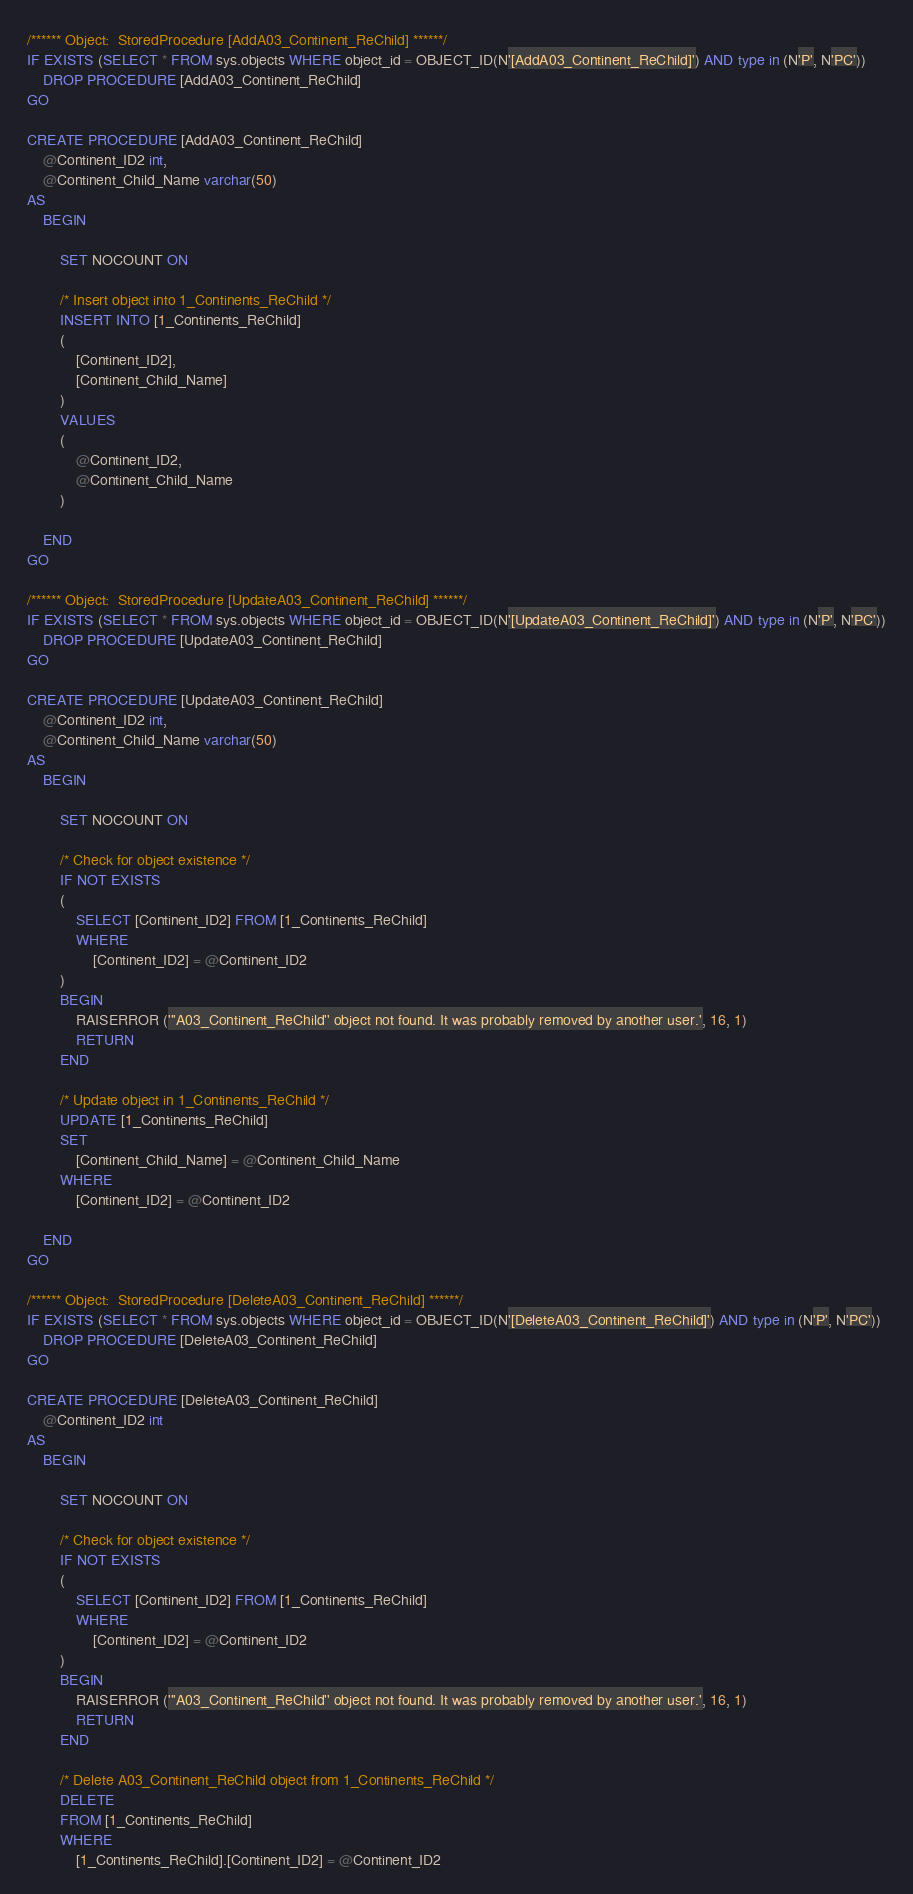<code> <loc_0><loc_0><loc_500><loc_500><_SQL_>/****** Object:  StoredProcedure [AddA03_Continent_ReChild] ******/
IF EXISTS (SELECT * FROM sys.objects WHERE object_id = OBJECT_ID(N'[AddA03_Continent_ReChild]') AND type in (N'P', N'PC'))
    DROP PROCEDURE [AddA03_Continent_ReChild]
GO

CREATE PROCEDURE [AddA03_Continent_ReChild]
    @Continent_ID2 int,
    @Continent_Child_Name varchar(50)
AS
    BEGIN

        SET NOCOUNT ON

        /* Insert object into 1_Continents_ReChild */
        INSERT INTO [1_Continents_ReChild]
        (
            [Continent_ID2],
            [Continent_Child_Name]
        )
        VALUES
        (
            @Continent_ID2,
            @Continent_Child_Name
        )

    END
GO

/****** Object:  StoredProcedure [UpdateA03_Continent_ReChild] ******/
IF EXISTS (SELECT * FROM sys.objects WHERE object_id = OBJECT_ID(N'[UpdateA03_Continent_ReChild]') AND type in (N'P', N'PC'))
    DROP PROCEDURE [UpdateA03_Continent_ReChild]
GO

CREATE PROCEDURE [UpdateA03_Continent_ReChild]
    @Continent_ID2 int,
    @Continent_Child_Name varchar(50)
AS
    BEGIN

        SET NOCOUNT ON

        /* Check for object existence */
        IF NOT EXISTS
        (
            SELECT [Continent_ID2] FROM [1_Continents_ReChild]
            WHERE
                [Continent_ID2] = @Continent_ID2
        )
        BEGIN
            RAISERROR ('''A03_Continent_ReChild'' object not found. It was probably removed by another user.', 16, 1)
            RETURN
        END

        /* Update object in 1_Continents_ReChild */
        UPDATE [1_Continents_ReChild]
        SET
            [Continent_Child_Name] = @Continent_Child_Name
        WHERE
            [Continent_ID2] = @Continent_ID2

    END
GO

/****** Object:  StoredProcedure [DeleteA03_Continent_ReChild] ******/
IF EXISTS (SELECT * FROM sys.objects WHERE object_id = OBJECT_ID(N'[DeleteA03_Continent_ReChild]') AND type in (N'P', N'PC'))
    DROP PROCEDURE [DeleteA03_Continent_ReChild]
GO

CREATE PROCEDURE [DeleteA03_Continent_ReChild]
    @Continent_ID2 int
AS
    BEGIN

        SET NOCOUNT ON

        /* Check for object existence */
        IF NOT EXISTS
        (
            SELECT [Continent_ID2] FROM [1_Continents_ReChild]
            WHERE
                [Continent_ID2] = @Continent_ID2
        )
        BEGIN
            RAISERROR ('''A03_Continent_ReChild'' object not found. It was probably removed by another user.', 16, 1)
            RETURN
        END

        /* Delete A03_Continent_ReChild object from 1_Continents_ReChild */
        DELETE
        FROM [1_Continents_ReChild]
        WHERE
            [1_Continents_ReChild].[Continent_ID2] = @Continent_ID2
</code> 